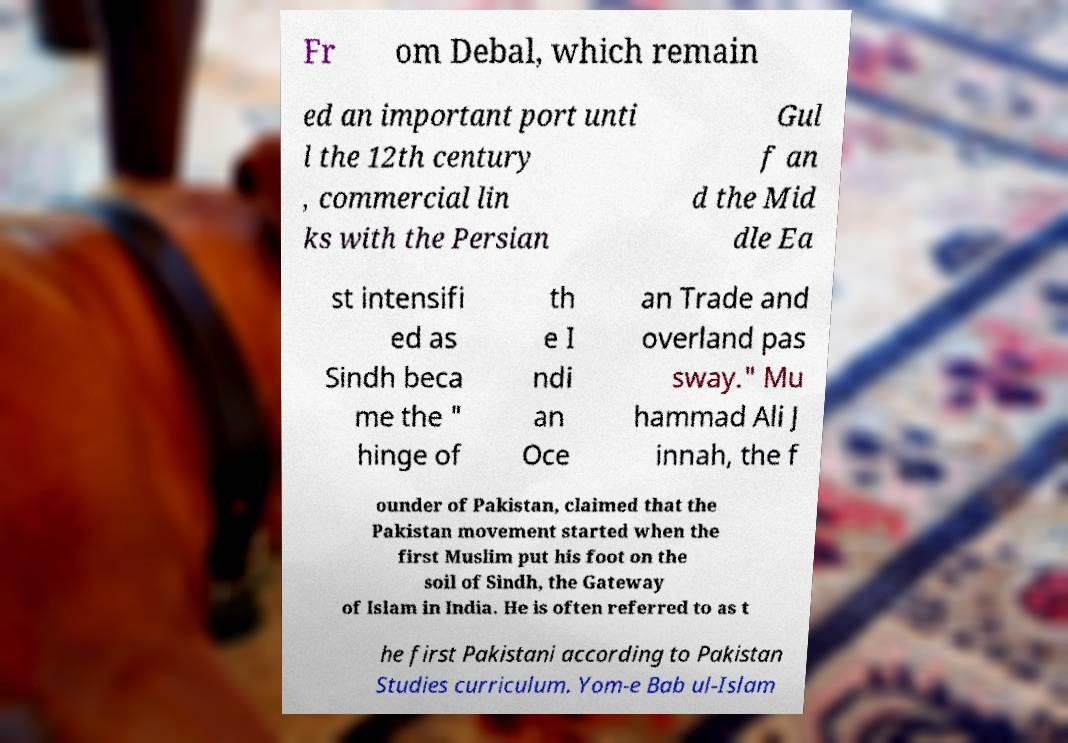Please identify and transcribe the text found in this image. Fr om Debal, which remain ed an important port unti l the 12th century , commercial lin ks with the Persian Gul f an d the Mid dle Ea st intensifi ed as Sindh beca me the " hinge of th e I ndi an Oce an Trade and overland pas sway." Mu hammad Ali J innah, the f ounder of Pakistan, claimed that the Pakistan movement started when the first Muslim put his foot on the soil of Sindh, the Gateway of Islam in India. He is often referred to as t he first Pakistani according to Pakistan Studies curriculum. Yom-e Bab ul-Islam 